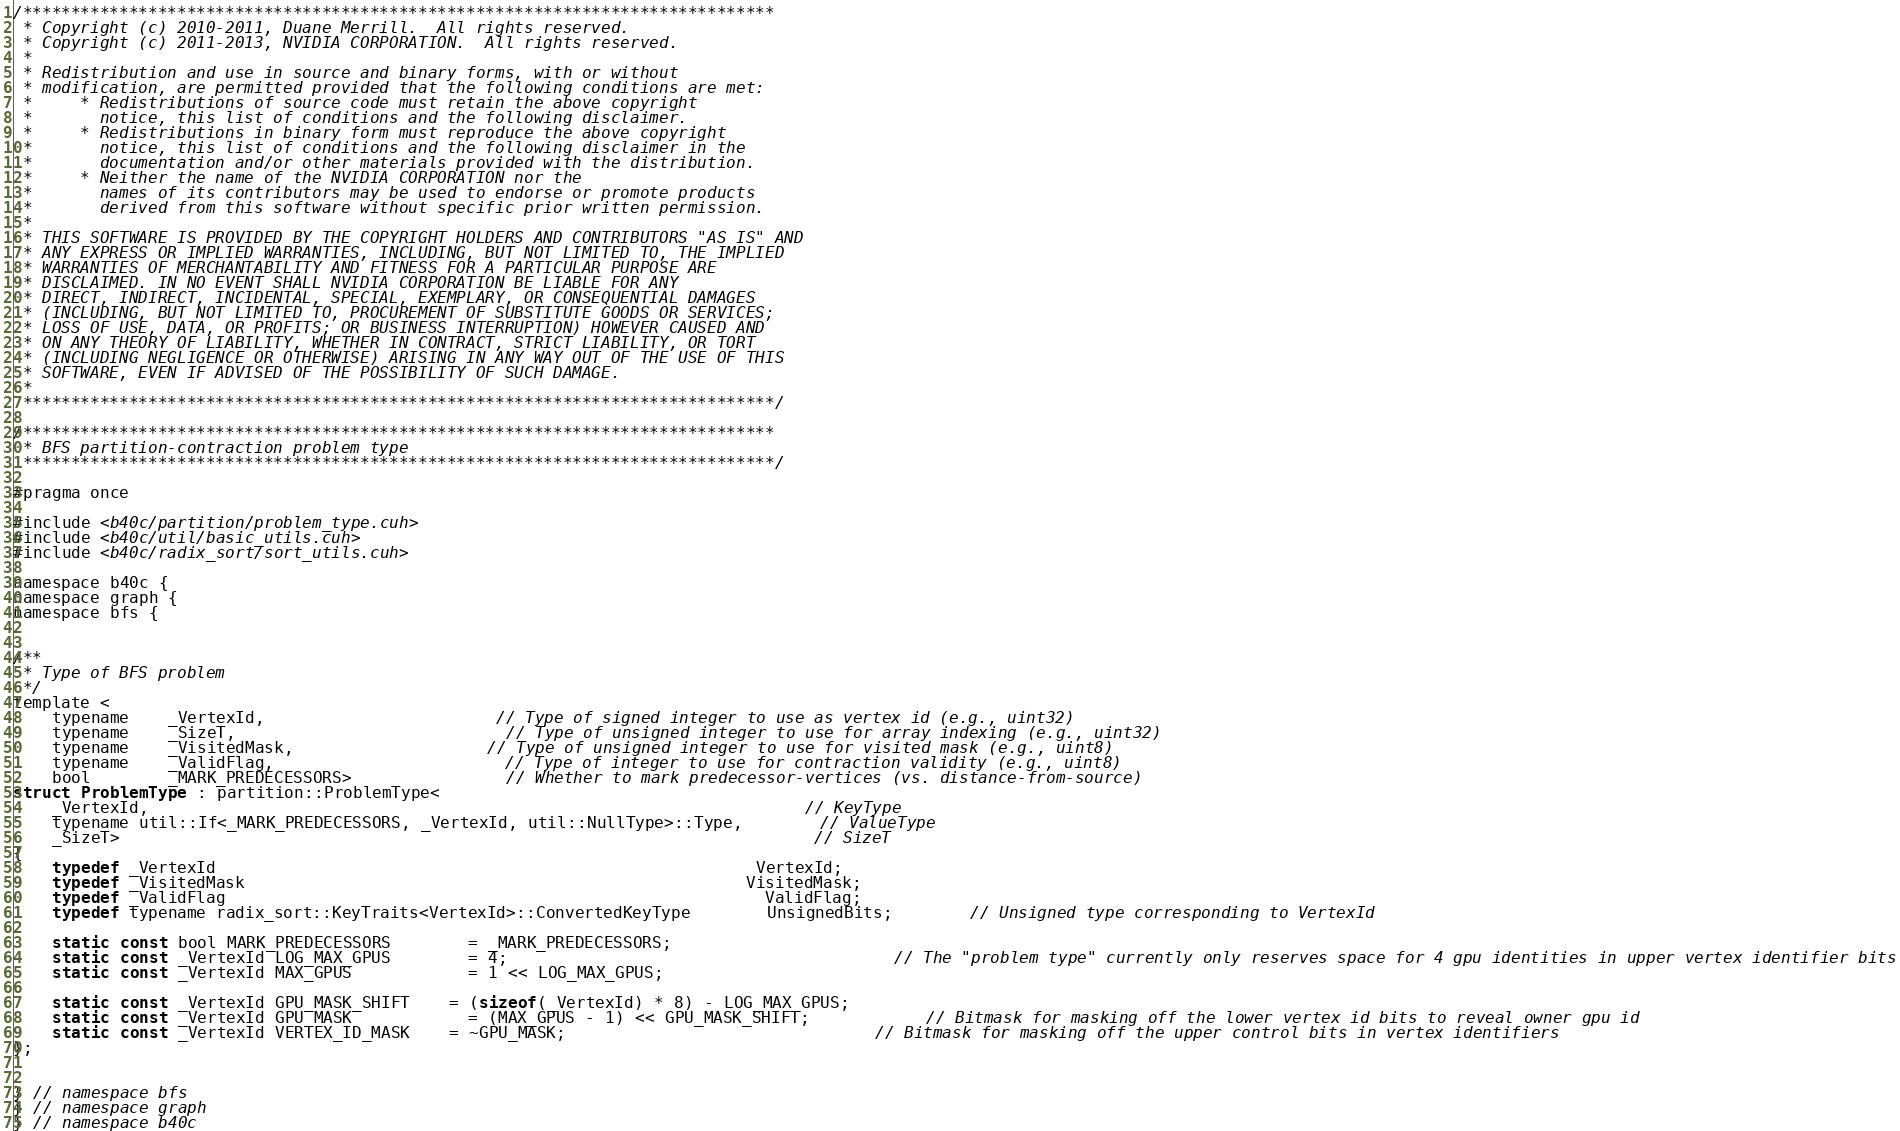Convert code to text. <code><loc_0><loc_0><loc_500><loc_500><_Cuda_>/******************************************************************************
 * Copyright (c) 2010-2011, Duane Merrill.  All rights reserved.
 * Copyright (c) 2011-2013, NVIDIA CORPORATION.  All rights reserved.
 * 
 * Redistribution and use in source and binary forms, with or without
 * modification, are permitted provided that the following conditions are met:
 *     * Redistributions of source code must retain the above copyright
 *       notice, this list of conditions and the following disclaimer.
 *     * Redistributions in binary form must reproduce the above copyright
 *       notice, this list of conditions and the following disclaimer in the
 *       documentation and/or other materials provided with the distribution.
 *     * Neither the name of the NVIDIA CORPORATION nor the
 *       names of its contributors may be used to endorse or promote products
 *       derived from this software without specific prior written permission.
 * 
 * THIS SOFTWARE IS PROVIDED BY THE COPYRIGHT HOLDERS AND CONTRIBUTORS "AS IS" AND
 * ANY EXPRESS OR IMPLIED WARRANTIES, INCLUDING, BUT NOT LIMITED TO, THE IMPLIED
 * WARRANTIES OF MERCHANTABILITY AND FITNESS FOR A PARTICULAR PURPOSE ARE
 * DISCLAIMED. IN NO EVENT SHALL NVIDIA CORPORATION BE LIABLE FOR ANY
 * DIRECT, INDIRECT, INCIDENTAL, SPECIAL, EXEMPLARY, OR CONSEQUENTIAL DAMAGES
 * (INCLUDING, BUT NOT LIMITED TO, PROCUREMENT OF SUBSTITUTE GOODS OR SERVICES;
 * LOSS OF USE, DATA, OR PROFITS; OR BUSINESS INTERRUPTION) HOWEVER CAUSED AND
 * ON ANY THEORY OF LIABILITY, WHETHER IN CONTRACT, STRICT LIABILITY, OR TORT
 * (INCLUDING NEGLIGENCE OR OTHERWISE) ARISING IN ANY WAY OUT OF THE USE OF THIS
 * SOFTWARE, EVEN IF ADVISED OF THE POSSIBILITY OF SUCH DAMAGE.
 *
 ******************************************************************************/

/******************************************************************************
 * BFS partition-contraction problem type
 ******************************************************************************/

#pragma once

#include <b40c/partition/problem_type.cuh>
#include <b40c/util/basic_utils.cuh>
#include <b40c/radix_sort/sort_utils.cuh>

namespace b40c {
namespace graph {
namespace bfs {


/**
 * Type of BFS problem
 */
template <
	typename 	_VertexId,						// Type of signed integer to use as vertex id (e.g., uint32)
	typename 	_SizeT,							// Type of unsigned integer to use for array indexing (e.g., uint32)
	typename 	_VisitedMask,					// Type of unsigned integer to use for visited mask (e.g., uint8)
	typename 	_ValidFlag,						// Type of integer to use for contraction validity (e.g., uint8)
	bool 		_MARK_PREDECESSORS>				// Whether to mark predecessor-vertices (vs. distance-from-source)
struct ProblemType : partition::ProblemType<
	_VertexId, 																	// KeyType
	typename util::If<_MARK_PREDECESSORS, _VertexId, util::NullType>::Type,		// ValueType
	_SizeT>																		// SizeT
{
	typedef _VertexId														VertexId;
	typedef _VisitedMask													VisitedMask;
	typedef _ValidFlag														ValidFlag;
	typedef typename radix_sort::KeyTraits<VertexId>::ConvertedKeyType		UnsignedBits;		// Unsigned type corresponding to VertexId

	static const bool MARK_PREDECESSORS		= _MARK_PREDECESSORS;
	static const _VertexId LOG_MAX_GPUS		= 4;										// The "problem type" currently only reserves space for 4 gpu identities in upper vertex identifier bits
	static const _VertexId MAX_GPUS			= 1 << LOG_MAX_GPUS;

	static const _VertexId GPU_MASK_SHIFT	= (sizeof(_VertexId) * 8) - LOG_MAX_GPUS;
	static const _VertexId GPU_MASK			= (MAX_GPUS - 1) << GPU_MASK_SHIFT;			// Bitmask for masking off the lower vertex id bits to reveal owner gpu id
	static const _VertexId VERTEX_ID_MASK	= ~GPU_MASK;								// Bitmask for masking off the upper control bits in vertex identifiers
};


} // namespace bfs
} // namespace graph
} // namespace b40c

</code> 